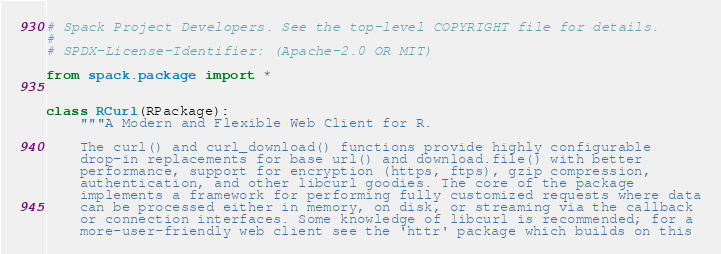Convert code to text. <code><loc_0><loc_0><loc_500><loc_500><_Python_># Spack Project Developers. See the top-level COPYRIGHT file for details.
#
# SPDX-License-Identifier: (Apache-2.0 OR MIT)

from spack.package import *


class RCurl(RPackage):
    """A Modern and Flexible Web Client for R.

    The curl() and curl_download() functions provide highly configurable
    drop-in replacements for base url() and download.file() with better
    performance, support for encryption (https, ftps), gzip compression,
    authentication, and other libcurl goodies. The core of the package
    implements a framework for performing fully customized requests where data
    can be processed either in memory, on disk, or streaming via the callback
    or connection interfaces. Some knowledge of libcurl is recommended; for a
    more-user-friendly web client see the 'httr' package which builds on this</code> 